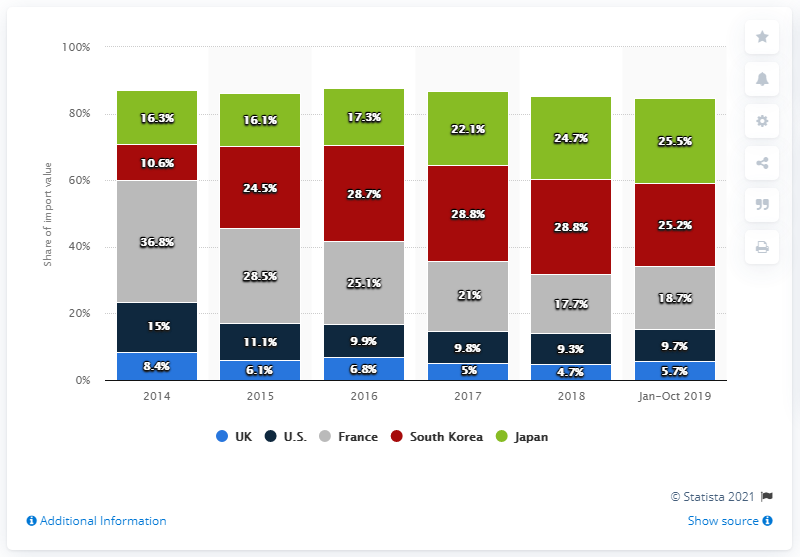List a handful of essential elements in this visual. In 2019, Japanese cosmetic products accounted for approximately 25.5% of total cosmetics imports during the period of January to October. 